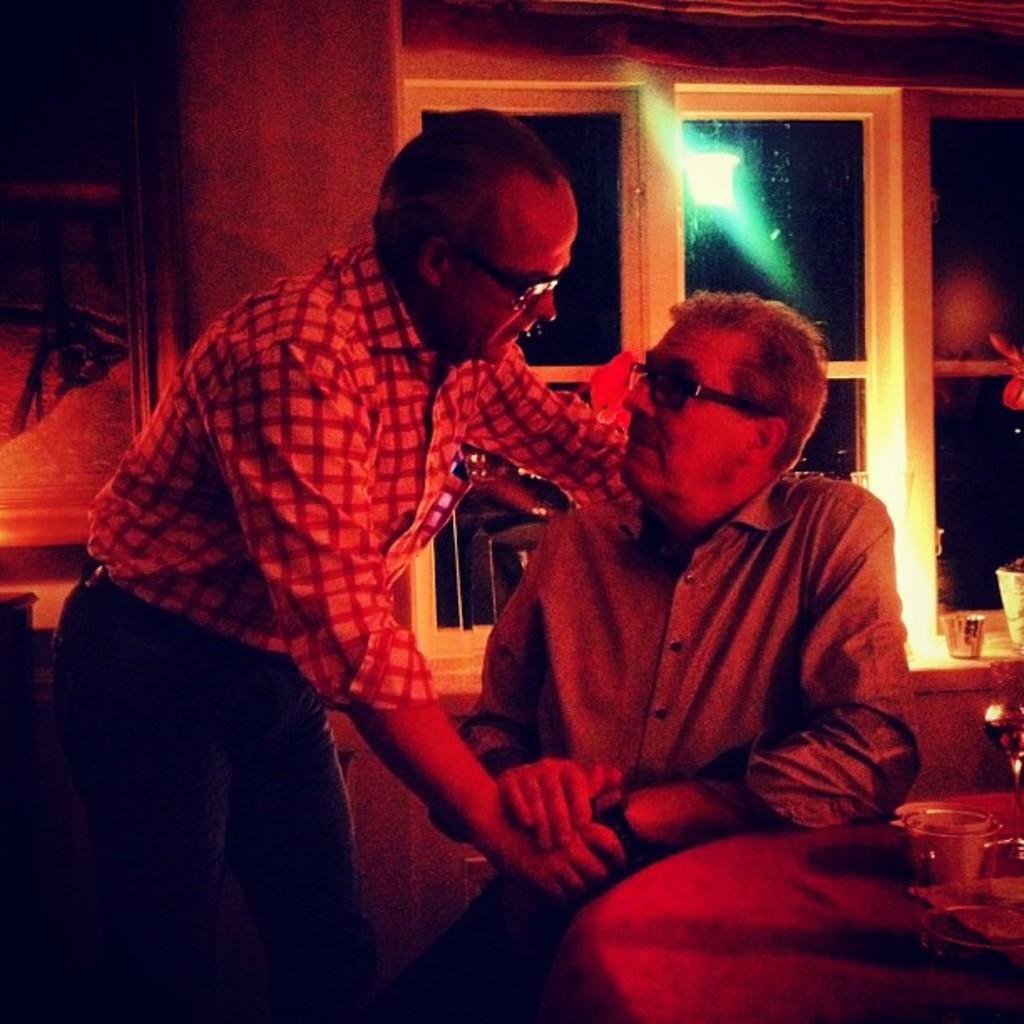Could you give a brief overview of what you see in this image? In this image I can see two persons. The person at right is sitting on the chair and the person at left is standing. Background I can see few glass windows. 